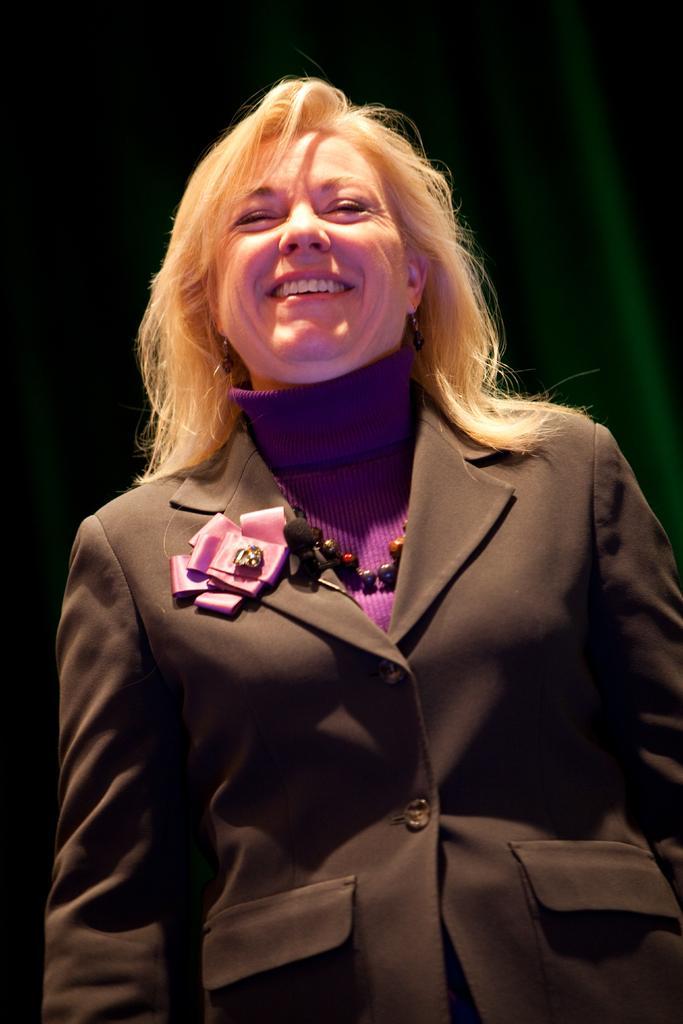Describe this image in one or two sentences. In this image I can see a woman in the front and I can also see smile on her face. I can see she is wearing black blazer. 